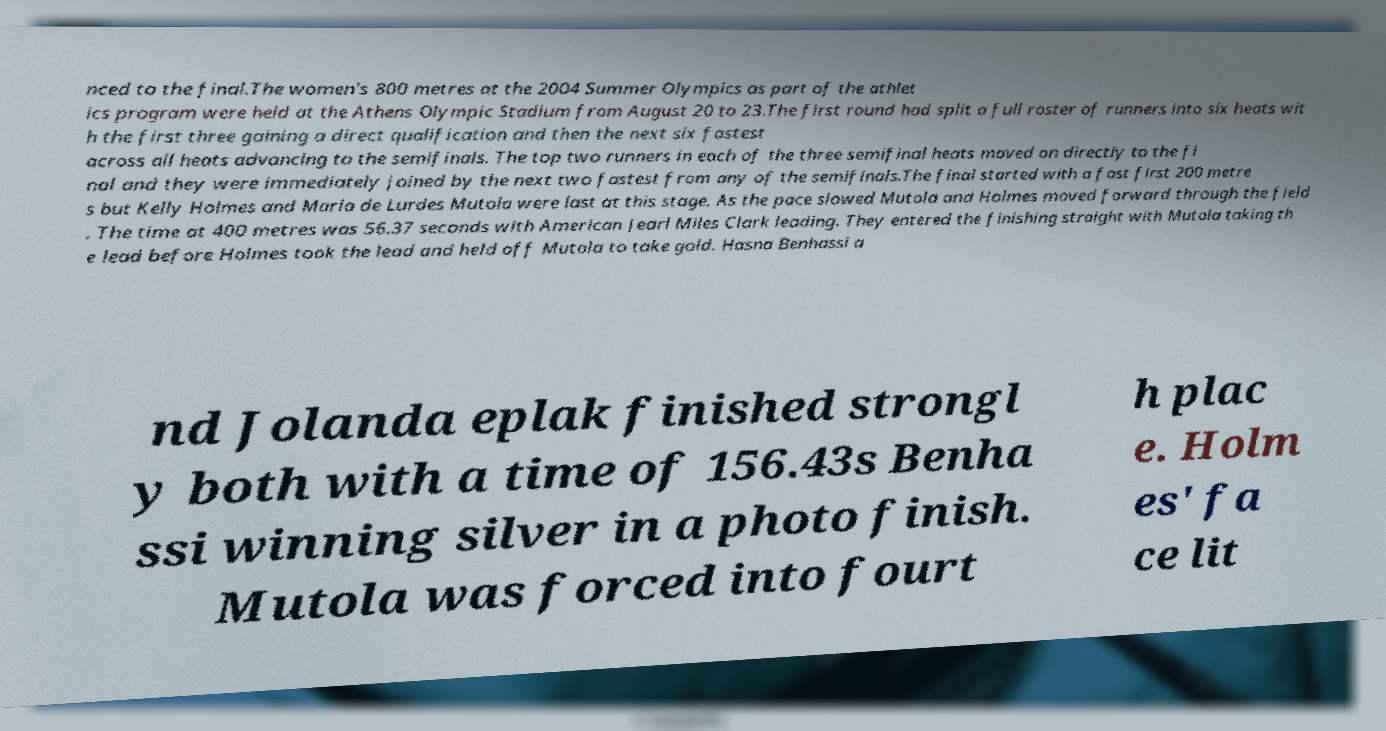For documentation purposes, I need the text within this image transcribed. Could you provide that? nced to the final.The women's 800 metres at the 2004 Summer Olympics as part of the athlet ics program were held at the Athens Olympic Stadium from August 20 to 23.The first round had split a full roster of runners into six heats wit h the first three gaining a direct qualification and then the next six fastest across all heats advancing to the semifinals. The top two runners in each of the three semifinal heats moved on directly to the fi nal and they were immediately joined by the next two fastest from any of the semifinals.The final started with a fast first 200 metre s but Kelly Holmes and Maria de Lurdes Mutola were last at this stage. As the pace slowed Mutola and Holmes moved forward through the field . The time at 400 metres was 56.37 seconds with American Jearl Miles Clark leading. They entered the finishing straight with Mutola taking th e lead before Holmes took the lead and held off Mutola to take gold. Hasna Benhassi a nd Jolanda eplak finished strongl y both with a time of 156.43s Benha ssi winning silver in a photo finish. Mutola was forced into fourt h plac e. Holm es' fa ce lit 